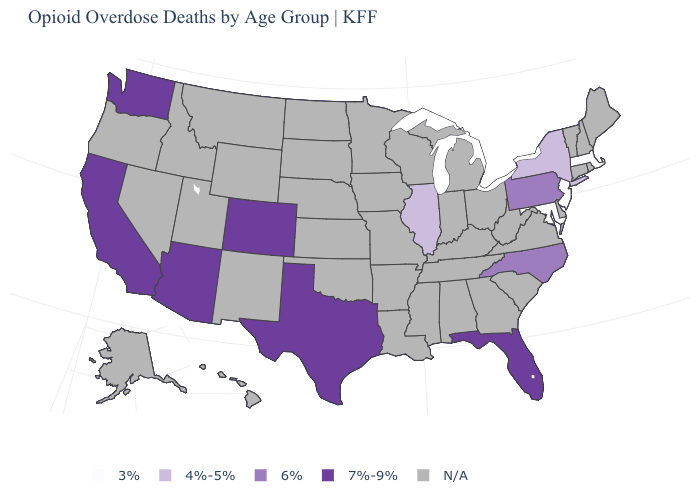Name the states that have a value in the range 4%-5%?
Quick response, please. Illinois, New York. Does the first symbol in the legend represent the smallest category?
Short answer required. Yes. What is the value of Connecticut?
Answer briefly. N/A. Name the states that have a value in the range N/A?
Answer briefly. Alabama, Alaska, Arkansas, Connecticut, Delaware, Georgia, Hawaii, Idaho, Indiana, Iowa, Kansas, Kentucky, Louisiana, Maine, Michigan, Minnesota, Mississippi, Missouri, Montana, Nebraska, Nevada, New Hampshire, New Mexico, North Dakota, Ohio, Oklahoma, Oregon, Rhode Island, South Carolina, South Dakota, Tennessee, Utah, Vermont, Virginia, West Virginia, Wisconsin, Wyoming. What is the value of Washington?
Give a very brief answer. 7%-9%. Among the states that border Pennsylvania , which have the highest value?
Short answer required. New York. What is the value of West Virginia?
Concise answer only. N/A. What is the value of New Hampshire?
Keep it brief. N/A. Name the states that have a value in the range 7%-9%?
Keep it brief. Arizona, California, Colorado, Florida, Texas, Washington. Name the states that have a value in the range 4%-5%?
Keep it brief. Illinois, New York. Does North Carolina have the highest value in the South?
Short answer required. No. Does New Jersey have the highest value in the Northeast?
Give a very brief answer. No. Which states have the lowest value in the USA?
Answer briefly. Maryland, Massachusetts, New Jersey. 